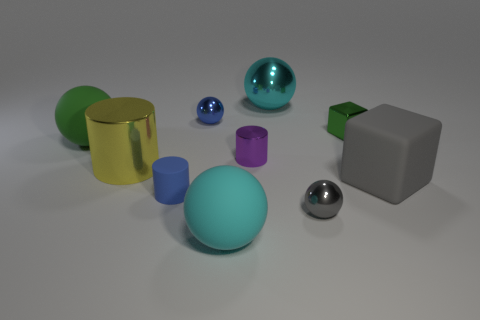Aside from the large green sphere, do any other objects have distinctive textures or features? Yes, the rubber cylinder has a distinctive matte finish, and the small reflective metal ball has a smooth, shiny surface. Additionally, the yellow cylinder on the left has a reflective metallic finish, making it stand out alongside the translucent blue sphere which allows light through, unlike the opaque objects. 